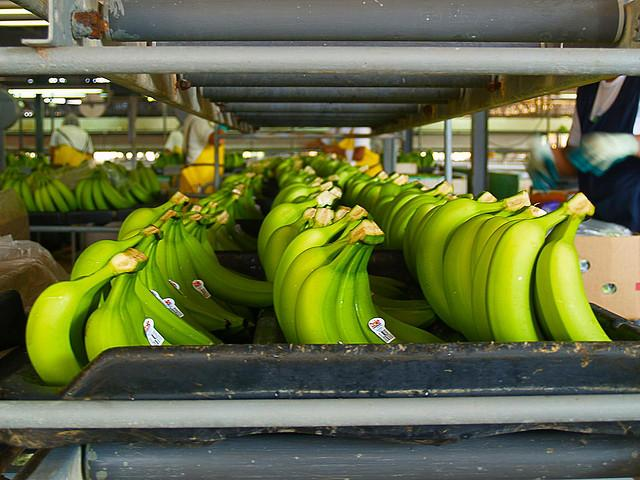Which food company produces these bananas?

Choices:
A) dole
B) bayer
C) coca-cola
D) chiquita dole 